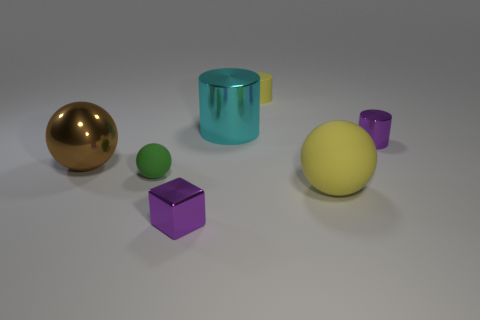How many green things are the same size as the shiny sphere?
Offer a very short reply. 0. Is the large yellow object made of the same material as the tiny purple object to the right of the big yellow object?
Ensure brevity in your answer.  No. Are there fewer purple cylinders than tiny cyan metallic cubes?
Give a very brief answer. No. Is there any other thing that is the same color as the large matte sphere?
Your answer should be very brief. Yes. The small thing that is made of the same material as the green ball is what shape?
Offer a terse response. Cylinder. What number of large brown balls are behind the small purple thing that is on the left side of the tiny thing that is right of the big yellow matte ball?
Keep it short and to the point. 1. There is a matte thing that is both behind the yellow ball and in front of the big cylinder; what shape is it?
Your answer should be very brief. Sphere. Are there fewer big metallic balls that are right of the rubber cylinder than brown metal balls?
Give a very brief answer. Yes. How many large objects are either yellow rubber things or purple things?
Your response must be concise. 1. The green ball has what size?
Your response must be concise. Small. 